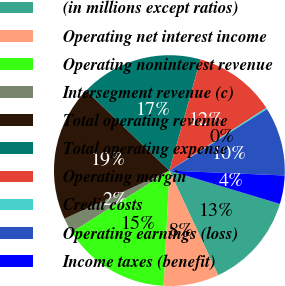Convert chart to OTSL. <chart><loc_0><loc_0><loc_500><loc_500><pie_chart><fcel>(in millions except ratios)<fcel>Operating net interest income<fcel>Operating noninterest revenue<fcel>Intersegment revenue (c)<fcel>Total operating revenue<fcel>Total operating expense<fcel>Operating margin<fcel>Credit costs<fcel>Operating earnings (loss)<fcel>Income taxes (benefit)<nl><fcel>13.39%<fcel>7.74%<fcel>15.27%<fcel>2.1%<fcel>19.03%<fcel>17.15%<fcel>11.51%<fcel>0.21%<fcel>9.62%<fcel>3.98%<nl></chart> 